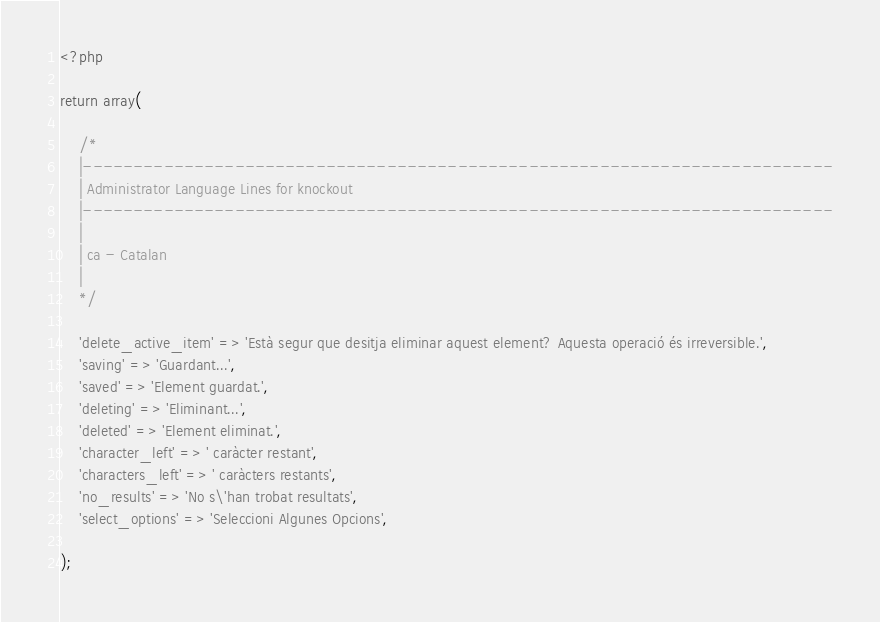<code> <loc_0><loc_0><loc_500><loc_500><_PHP_><?php 

return array(

	/*
	|--------------------------------------------------------------------------
	| Administrator Language Lines for knockout
	|--------------------------------------------------------------------------
	|
	| ca - Catalan
	|
	*/

	'delete_active_item' => 'Està segur que desitja eliminar aquest element? Aquesta operació és irreversible.',
	'saving' => 'Guardant...',
	'saved' => 'Element guardat.',
	'deleting' => 'Eliminant...',
	'deleted' => 'Element eliminat.',
	'character_left' => ' caràcter restant',
	'characters_left' => ' caràcters restants',
	'no_results' => 'No s\'han trobat resultats',
	'select_options' => 'Seleccioni Algunes Opcions',

);
</code> 